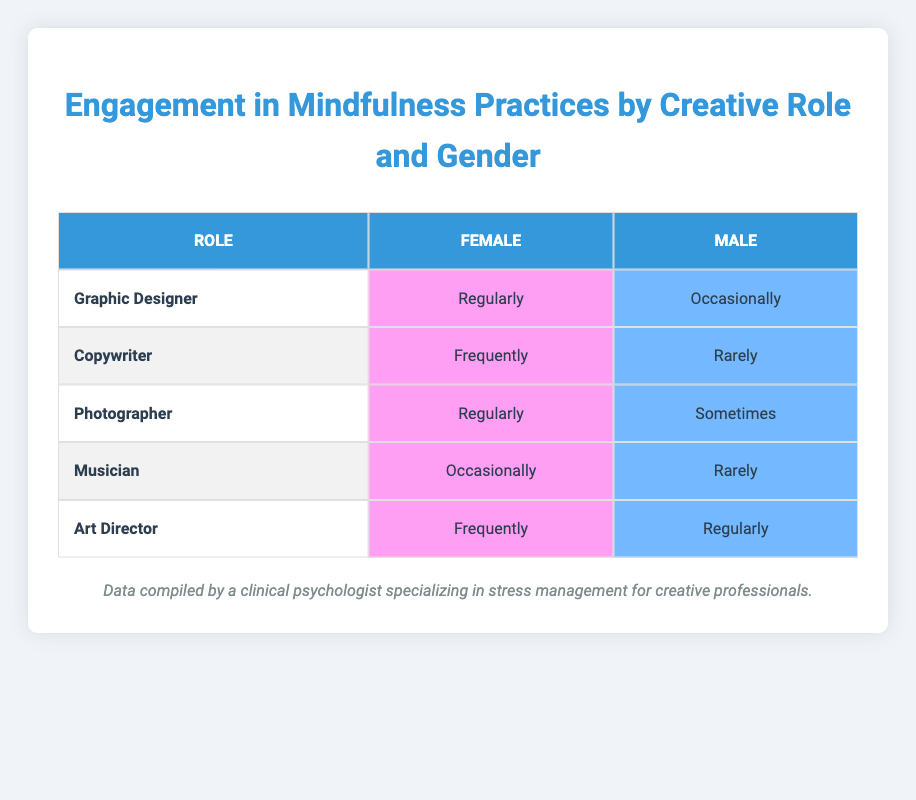What is the engagement in mindfulness practices for Female Graphic Designers? The table states that Female Graphic Designers engage in mindfulness practices "Regularly."
Answer: Regularly How many male musicians engage in mindfulness practices? According to the table, the engagement for Male Musicians is listed as "Rarely." Therefore, there is one entry for Male Musicians.
Answer: Rarely Which creative role has the highest engagement in mindfulness practices for females? By comparing the entries for females, both Graphic Designers and Photographers engage in mindfulness practices "Regularly," and the Copywriters and Art Directors do so "Frequently." Therefore, the highest frequency of engagement for females is "Regularly."
Answer: Graphic Designer and Photographer What is the difference in mindfulness practice engagement between Female Copywriters and Male Copywriters? Female Copywriters engage in mindfulness practices "Frequently," while Male Copywriters do so "Rarely." To find the difference, we assess the frequency levels. "Frequently" is higher than "Rarely."
Answer: Frequently is higher Is it true that Art Directors engage in mindfulness practices more often than Musicians? Yes, Female Art Directors engage "Frequently," and Male Art Directors engage "Regularly," while Female Musicians engage "Occasionally," and Male Musicians engage "Rarely." Since "Frequently" and "Regularly" are higher than "Occasionally" and "Rarely," the statement is true.
Answer: Yes What are the engagement practices for Male Photographers compared to Female Photographers? Male Photographers engage in mindfulness practices "Sometimes," while Female Photographers engage "Regularly." This shows Male Photographers engage less frequently than Female Photographers.
Answer: Less frequently How many creative roles have their male counterparts engaging in mindfulness practices "Regularly"? According to the table, only the role of Art Director has its male counterpart engaging "Regularly." The other roles have lower engagement.
Answer: One role What is the average engagement level in mindfulness practices for females across all roles? The female roles are Graphic Designer (Regularly), Copywriter (Frequently), Photographer (Regularly), Musician (Occasionally), and Art Director (Frequently). Converting these into a numerical scale could yield a summary: Regularly (3), Frequently (2), Occasionally (1). The total is (3+2+3+1+2) = 11 and there are 5 roles, hence the average is 11/5 = 2.2, which represents a weighted average that falls between "Frequently" and "Regularly."
Answer: Between Regularly and Frequently How many Female and Male roles engage in mindfulness practices "Regularly"? There are two Female roles (Graphic Designer and Photographer) and one Male role (Art Director) engaging "Regularly," totaling three in total who engage regularly.
Answer: Three roles 